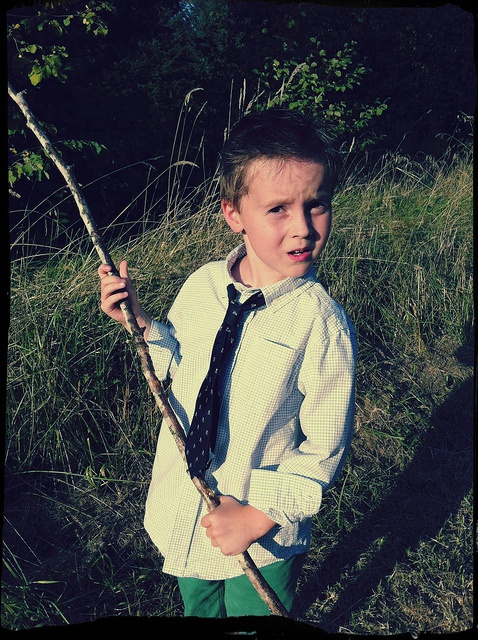Describe the objects in this image and their specific colors. I can see people in black, beige, tan, and darkgray tones and tie in black, navy, gray, and blue tones in this image. 